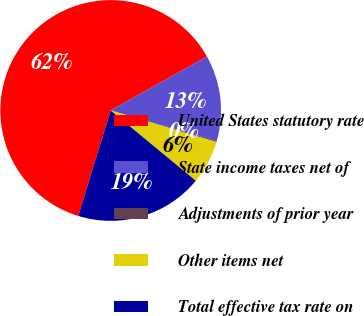<chart> <loc_0><loc_0><loc_500><loc_500><pie_chart><fcel>United States statutory rate<fcel>State income taxes net of<fcel>Adjustments of prior year<fcel>Other items net<fcel>Total effective tax rate on<nl><fcel>62.12%<fcel>12.57%<fcel>0.18%<fcel>6.37%<fcel>18.76%<nl></chart> 